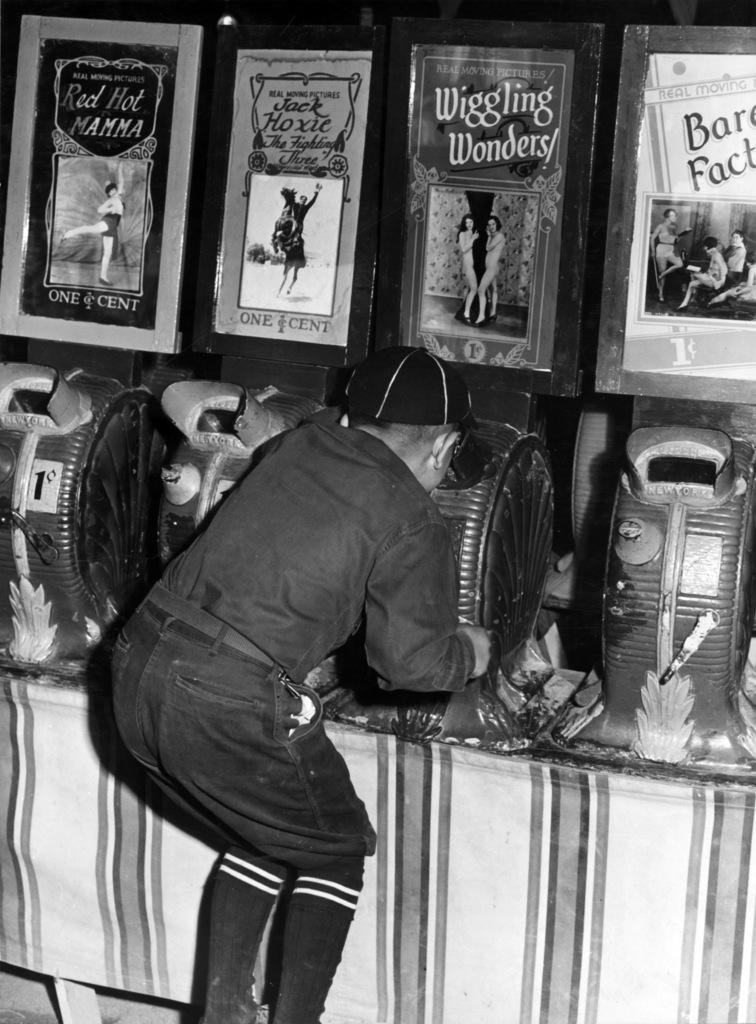Who or what is the main subject in the image? There is a person in the image. What can be seen in the background of the image? There is a table in the background of the image. What is placed on the table? There are objects placed on the table. What is visible at the top of the image? There are posters visible at the top of the image. What type of oatmeal is being prepared on the table in the image? There is no oatmeal present in the image, and no indication of any food preparation. 